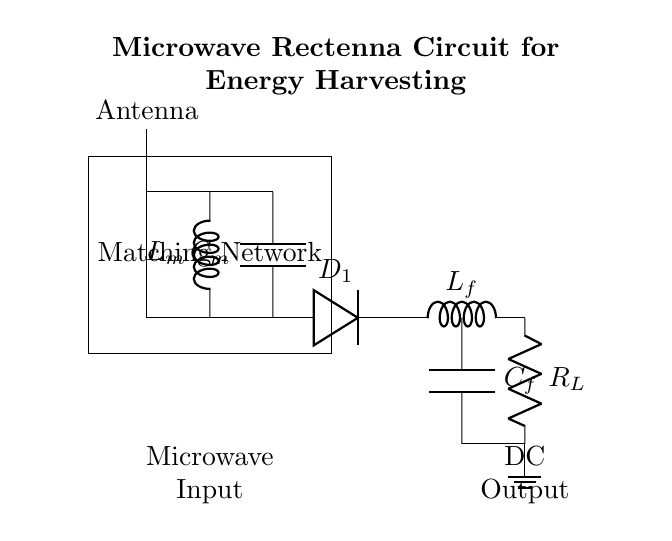What component receives microwave energy? The circuit diagram shows an antenna at the top, which is responsible for receiving microwave energy from electromagnetic waves.
Answer: Antenna What is the purpose of the matching network? The matching network, consisting of an inductor and a capacitor, is positioned between the antenna and the diode. Its purpose is to match the impedance of the antenna with that of the rest of the circuit, optimizing power transfer.
Answer: Impedance matching What component is used to rectify the microwave signal? The Schottky diode is indicated in the circuit and is specifically designed for rectifying high-frequency signals, thereby converting the received microwave energy into direct current.
Answer: Schottky diode Which components form the low-pass filter in this circuit? The low-pass filter consists of an inductor and a capacitor connected in series, which allows low-frequency signals (DC) to pass while blocking higher frequencies, ensuring a smooth output.
Answer: Inductor and capacitor What is the load resistor labeled in the diagram? The load resistor, marked as R_L, is positioned at the bottom right of the circuit diagram, representing the component where the harvested energy is utilized or drawn out of the rectenna circuit.
Answer: R_L Why is a ground connection important in this circuit? The ground connection is crucial for providing a reference point for voltages in the circuit. It stabilizes the operation of the rectenna and ensures safety by eliminating excess charge buildup.
Answer: Stability and safety How does energy conversion occur in this circuit? Energy conversion occurs when microwave energy is harvested by the antenna, passed through the matching network, rectified by the Schottky diode, filtered by the low-pass filter, and then supplied to the load resistor as DC output.
Answer: From microwave to DC output 